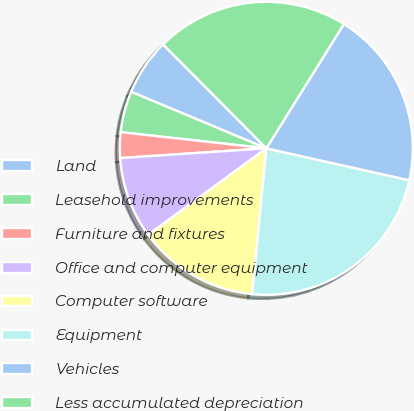Convert chart. <chart><loc_0><loc_0><loc_500><loc_500><pie_chart><fcel>Land<fcel>Leasehold improvements<fcel>Furniture and fixtures<fcel>Office and computer equipment<fcel>Computer software<fcel>Equipment<fcel>Vehicles<fcel>Less accumulated depreciation<nl><fcel>6.25%<fcel>4.54%<fcel>2.82%<fcel>9.0%<fcel>13.4%<fcel>23.04%<fcel>19.62%<fcel>21.33%<nl></chart> 